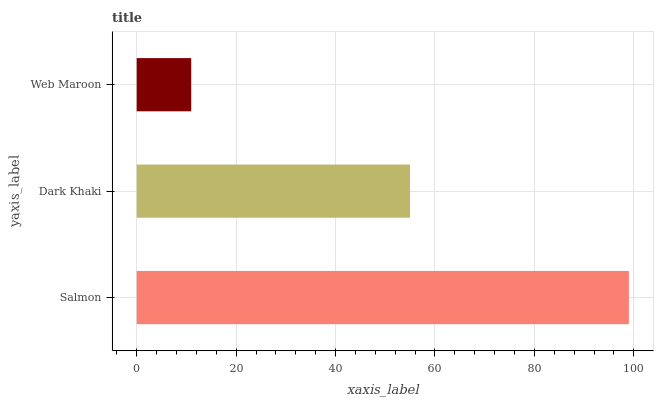Is Web Maroon the minimum?
Answer yes or no. Yes. Is Salmon the maximum?
Answer yes or no. Yes. Is Dark Khaki the minimum?
Answer yes or no. No. Is Dark Khaki the maximum?
Answer yes or no. No. Is Salmon greater than Dark Khaki?
Answer yes or no. Yes. Is Dark Khaki less than Salmon?
Answer yes or no. Yes. Is Dark Khaki greater than Salmon?
Answer yes or no. No. Is Salmon less than Dark Khaki?
Answer yes or no. No. Is Dark Khaki the high median?
Answer yes or no. Yes. Is Dark Khaki the low median?
Answer yes or no. Yes. Is Web Maroon the high median?
Answer yes or no. No. Is Salmon the low median?
Answer yes or no. No. 